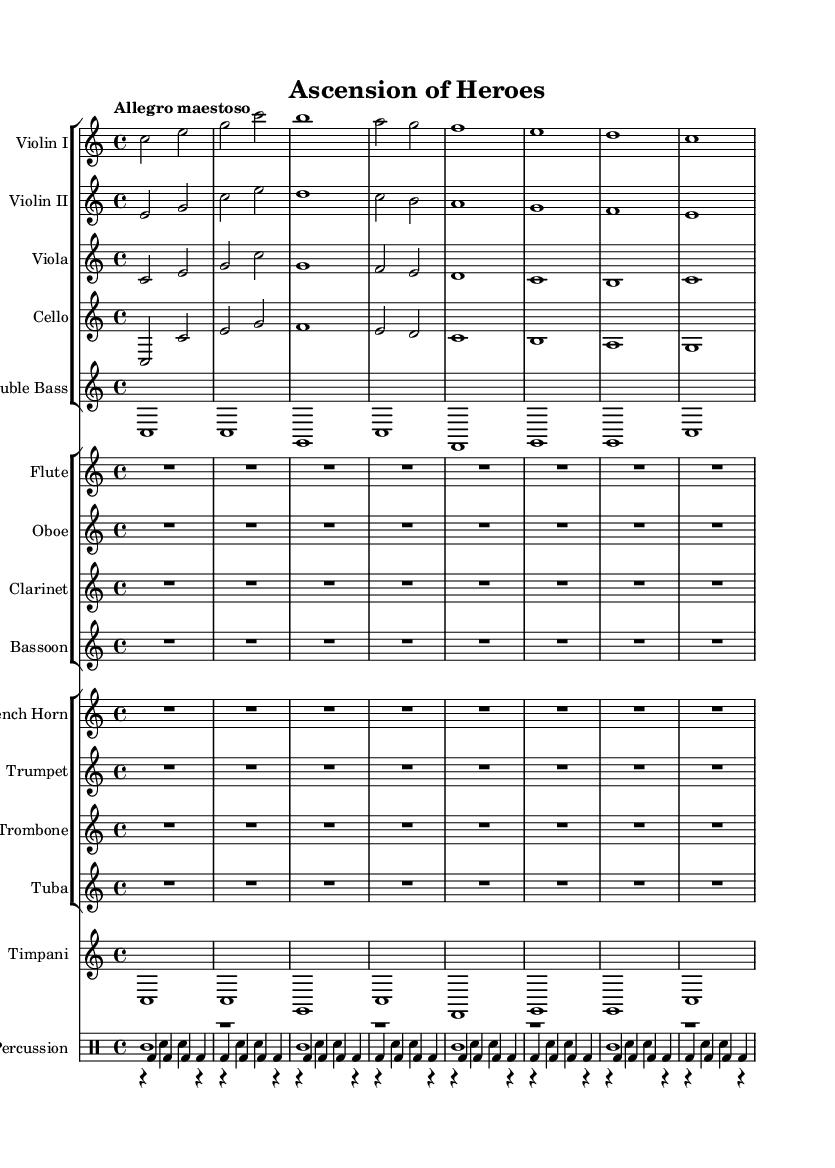What is the key signature of this music? The key signature shown at the beginning of the piece indicates the key is C major, which has no sharps or flats.
Answer: C major What is the time signature of this music? The time signature appears at the beginning, indicating that the music is structured in 4/4 time, meaning there are four beats in each measure.
Answer: 4/4 What is the tempo marking for this piece? The tempo is indicated by the word "Allegro maestoso," which translates to a fast and majestic tempo.
Answer: Allegro maestoso How many measures are present in the provided music? By counting the measures visually, there are a total of 16 measures displayed in the sheet music.
Answer: 16 Which instruments are primarily featured in the orchestration? The music features strings (Violin I, Violin II, Viola, Cello, Double Bass), woodwinds (Flute, Oboe, Clarinet, Bassoon), brass (French Horn, Trumpet, Trombone, Tuba), percussion (Timpani, Cymbals, Snare Drum, Bass Drum).
Answer: Strings, woodwinds, brass, percussion What is the highest note in the violin part throughout the piece? By analyzing the violin part, the highest note present is G, which occurs in the first measure.
Answer: G What type of composition is represented by this sheet music? This sheet music represents an epic orchestral score typically found in blockbuster action movies, characterized by grand themes and dramatic dynamics.
Answer: Epic orchestral score 